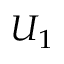Convert formula to latex. <formula><loc_0><loc_0><loc_500><loc_500>U _ { 1 }</formula> 